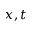<formula> <loc_0><loc_0><loc_500><loc_500>x , t</formula> 